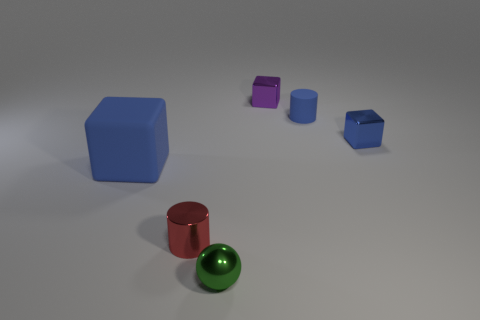Add 3 blue cylinders. How many objects exist? 9 Subtract all cylinders. How many objects are left? 4 Add 6 tiny red cylinders. How many tiny red cylinders are left? 7 Add 4 large blue objects. How many large blue objects exist? 5 Subtract 0 purple spheres. How many objects are left? 6 Subtract all small matte cubes. Subtract all tiny blue metal things. How many objects are left? 5 